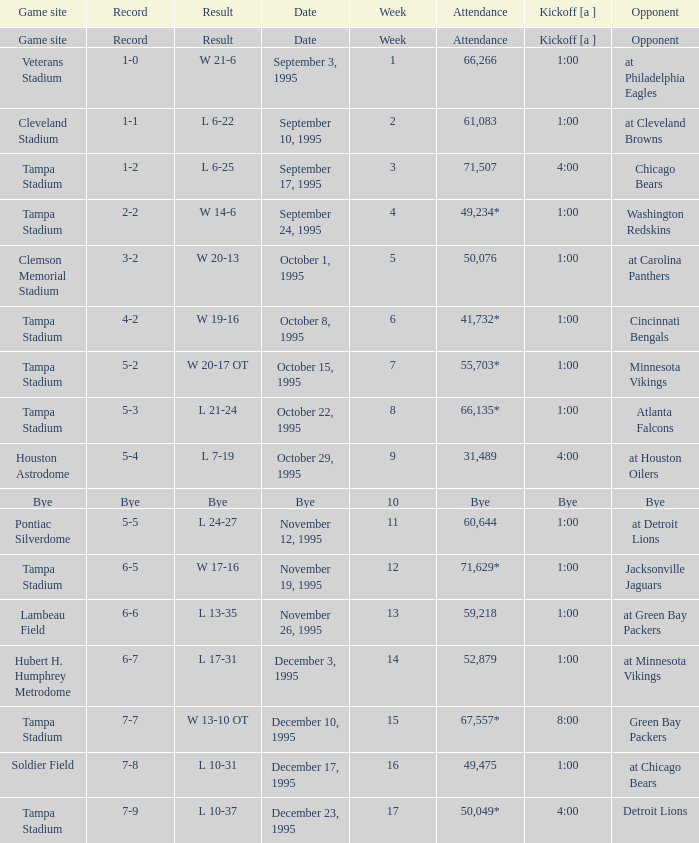On what date was Tampa Bay's Week 4 game? September 24, 1995. 